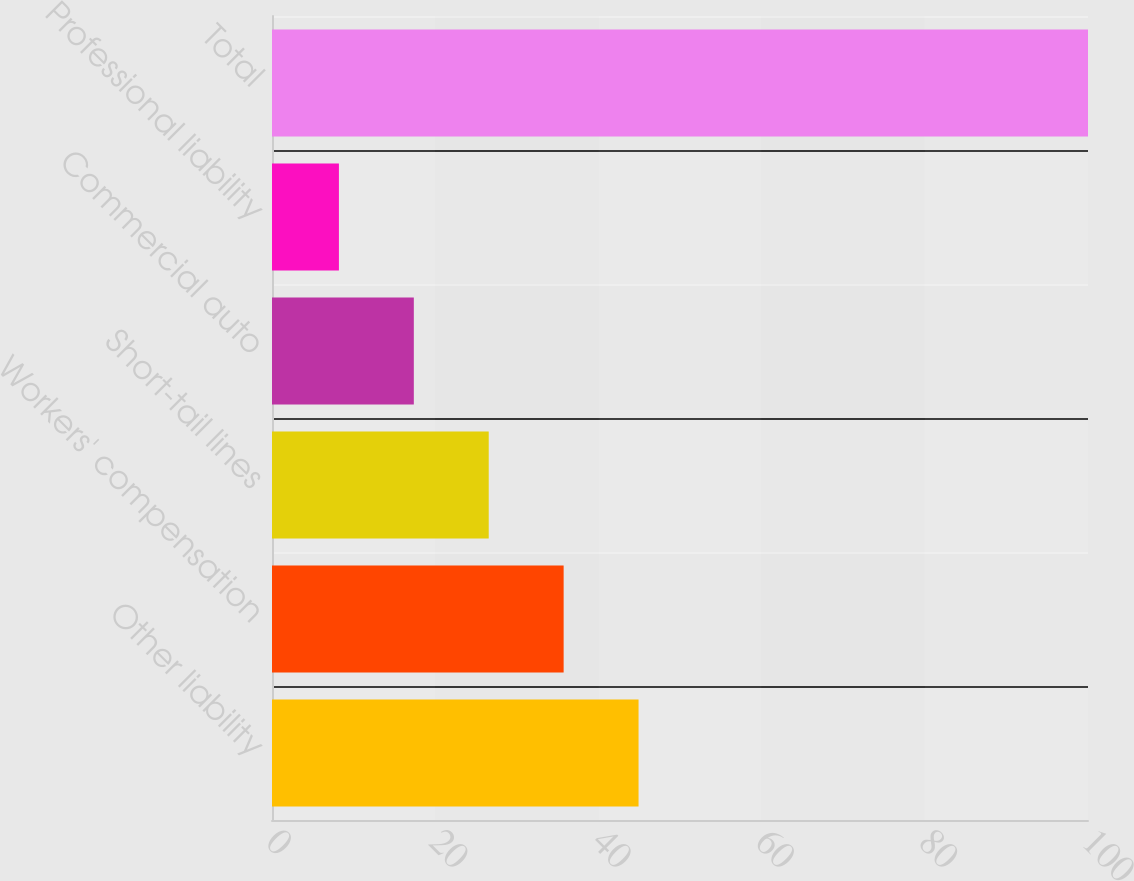Convert chart to OTSL. <chart><loc_0><loc_0><loc_500><loc_500><bar_chart><fcel>Other liability<fcel>Workers' compensation<fcel>Short-tail lines<fcel>Commercial auto<fcel>Professional liability<fcel>Total<nl><fcel>44.92<fcel>35.74<fcel>26.56<fcel>17.38<fcel>8.2<fcel>100<nl></chart> 